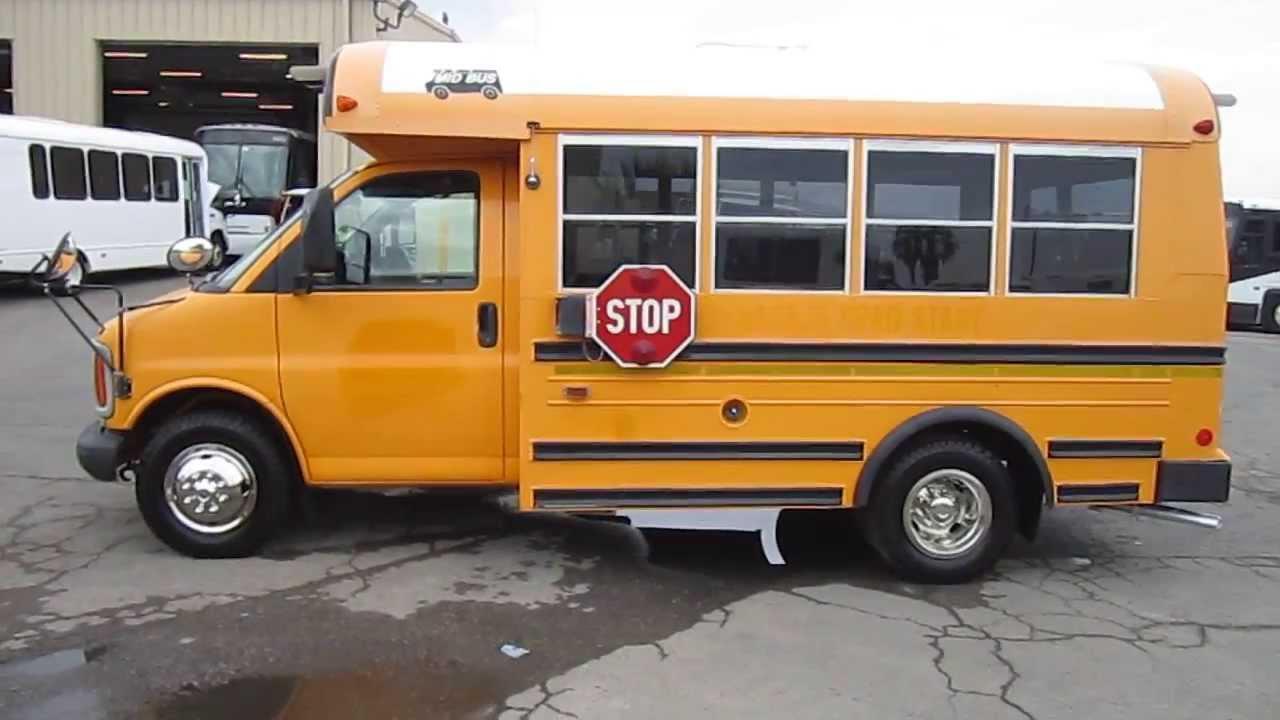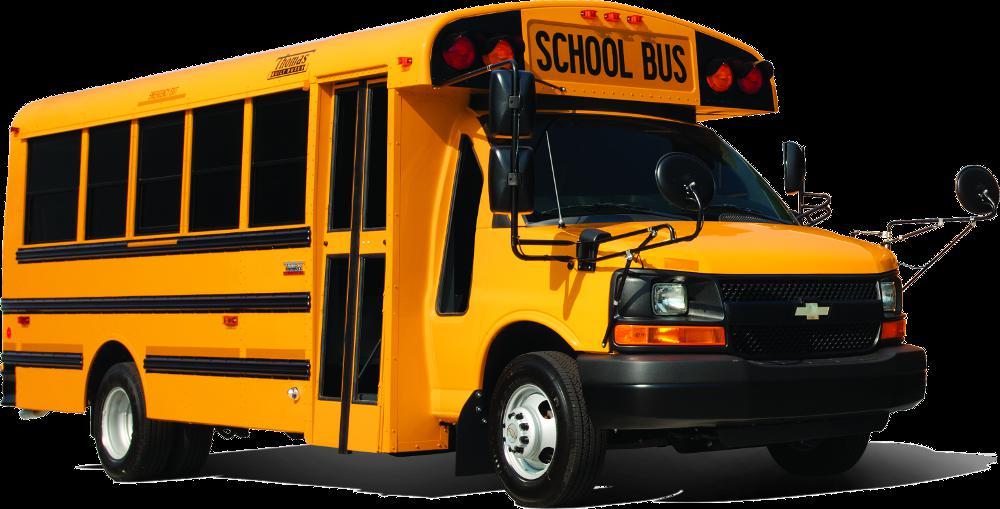The first image is the image on the left, the second image is the image on the right. Examine the images to the left and right. Is the description "Left and right images each contain one new-condition yellow bus with a sloped front instead of a flat front and no more than five passenger windows per side." accurate? Answer yes or no. Yes. The first image is the image on the left, the second image is the image on the right. Examine the images to the left and right. Is the description "Both buses are pointing to the right." accurate? Answer yes or no. No. 